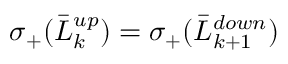Convert formula to latex. <formula><loc_0><loc_0><loc_500><loc_500>\sigma _ { + } ( \bar { L } _ { k } ^ { u p } ) = \sigma _ { + } ( \bar { L } _ { k + 1 } ^ { d o w n } )</formula> 